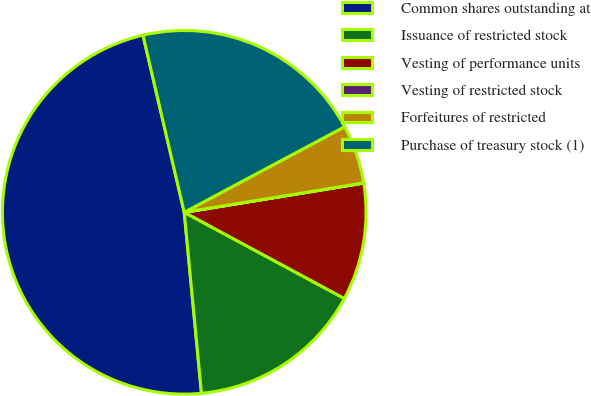Convert chart to OTSL. <chart><loc_0><loc_0><loc_500><loc_500><pie_chart><fcel>Common shares outstanding at<fcel>Issuance of restricted stock<fcel>Vesting of performance units<fcel>Vesting of restricted stock<fcel>Forfeitures of restricted<fcel>Purchase of treasury stock (1)<nl><fcel>47.87%<fcel>15.63%<fcel>10.43%<fcel>0.01%<fcel>5.22%<fcel>20.84%<nl></chart> 